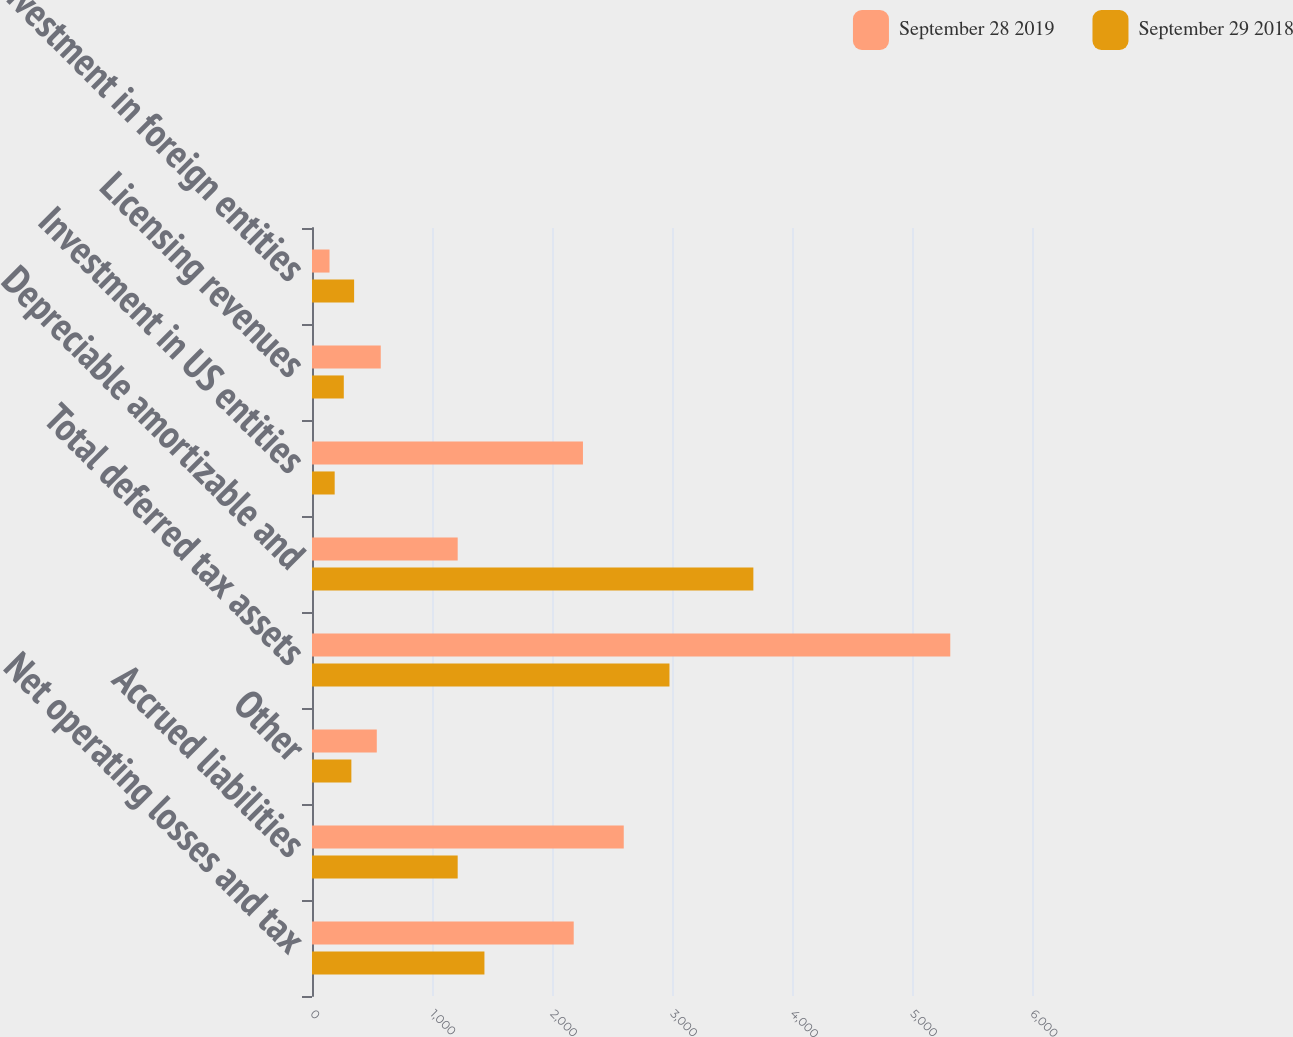<chart> <loc_0><loc_0><loc_500><loc_500><stacked_bar_chart><ecel><fcel>Net operating losses and tax<fcel>Accrued liabilities<fcel>Other<fcel>Total deferred tax assets<fcel>Depreciable amortizable and<fcel>Investment in US entities<fcel>Licensing revenues<fcel>Investment in foreign entities<nl><fcel>September 28 2019<fcel>2181<fcel>2598<fcel>540<fcel>5319<fcel>1214<fcel>2258<fcel>573<fcel>146<nl><fcel>September 29 2018<fcel>1437<fcel>1214<fcel>328<fcel>2979<fcel>3678<fcel>189<fcel>265<fcel>351<nl></chart> 